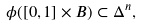Convert formula to latex. <formula><loc_0><loc_0><loc_500><loc_500>\phi ( [ 0 , 1 ] \times B ) \subset \Delta ^ { n } ,</formula> 